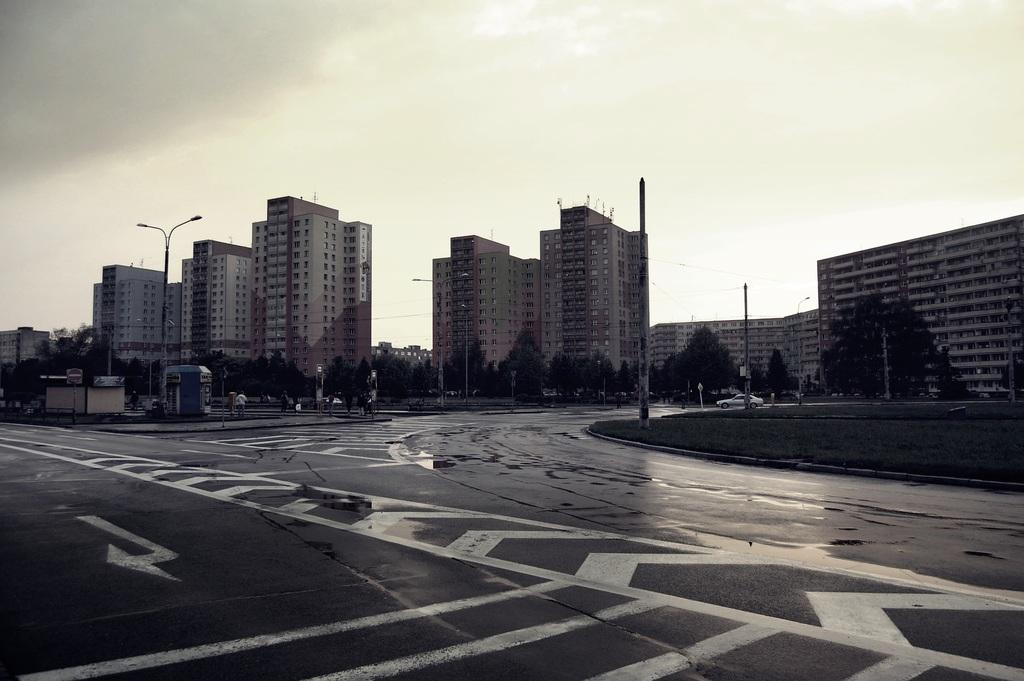What is the main subject of the image? The main subject of the image is a road. What can be seen in the background of the image? There are big buildings in the background. How would you describe the sky in the image? The sky is cloudy in the image. What type of lunch is being served at the elbow in the image? There is no mention of lunch or elbows in the image; it depicts a road with big buildings in the background and a cloudy sky. 